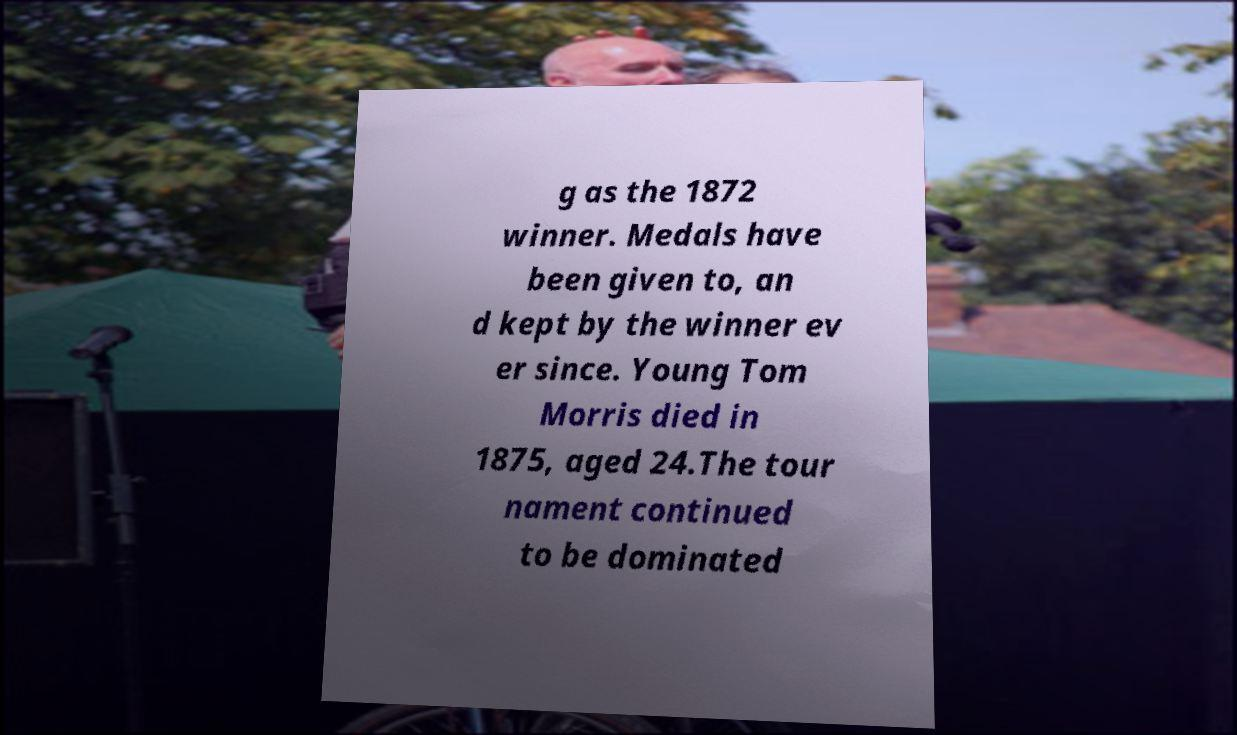For documentation purposes, I need the text within this image transcribed. Could you provide that? g as the 1872 winner. Medals have been given to, an d kept by the winner ev er since. Young Tom Morris died in 1875, aged 24.The tour nament continued to be dominated 